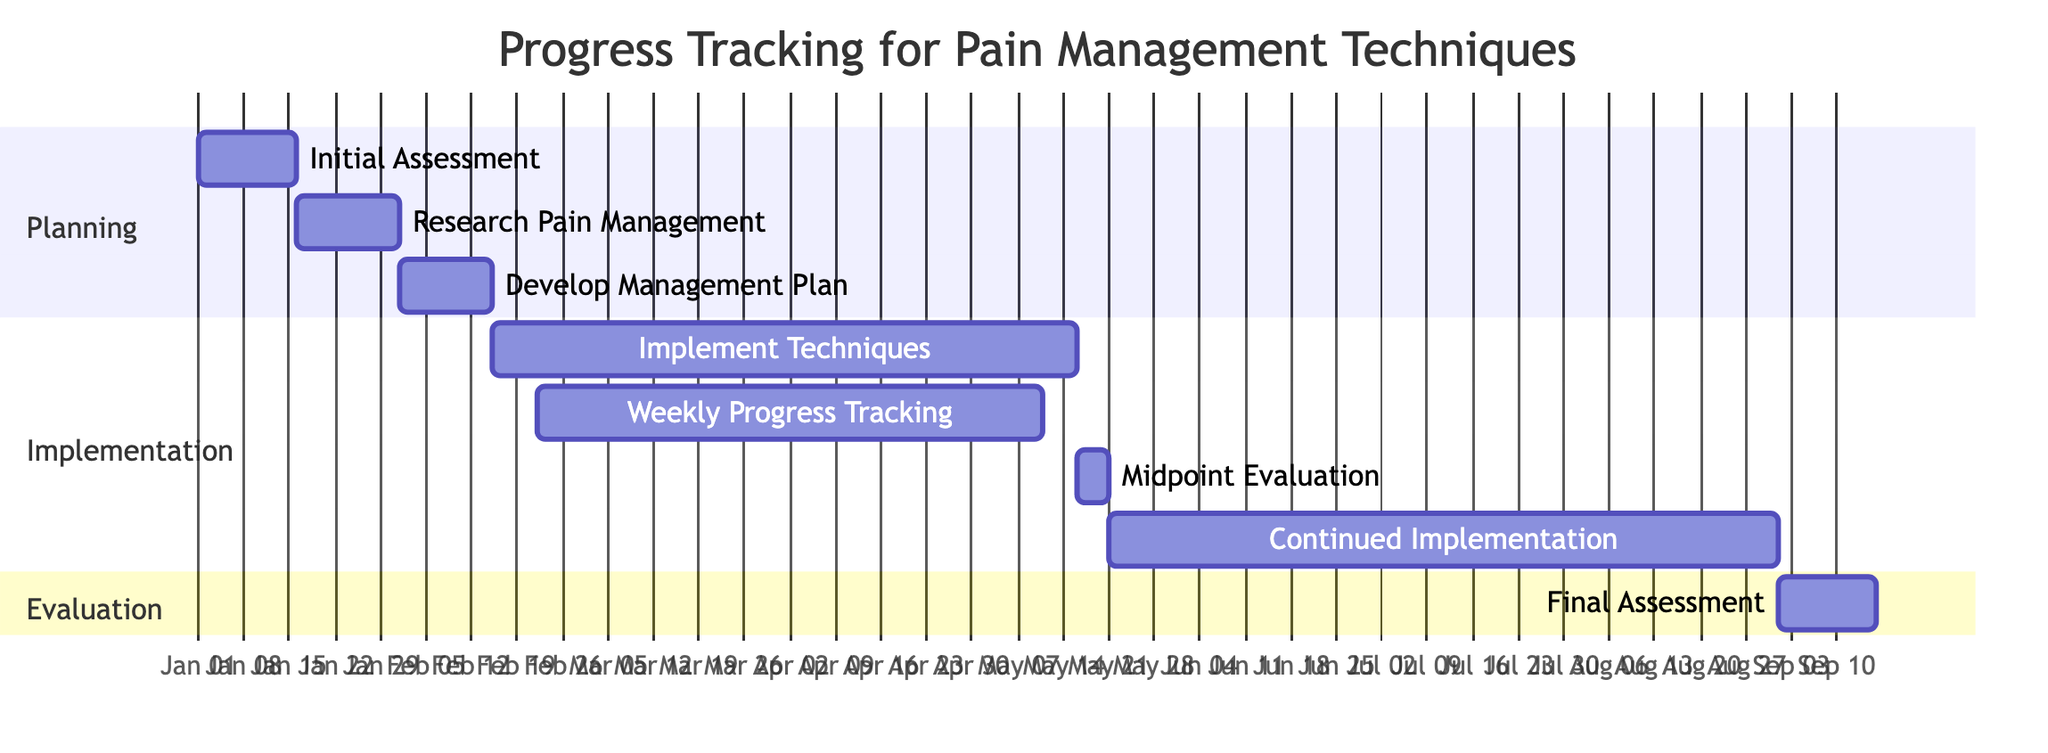What is the duration of the "Initial Assessment"? The "Initial Assessment" task starts on January 1, 2023, and ends on January 15, 2023, which means it lasts for 15 days.
Answer: 15 days What is the start date of "Weekly Progress Tracking"? "Weekly Progress Tracking" begins on February 22, 2023, as indicated in the diagram.
Answer: February 22, 2023 How many days is the "Midpoint Evaluation"? The "Midpoint Evaluation" task lasts from May 16 to May 20, 2023, which is 5 days long.
Answer: 5 days Which task follows "Research Pain Management Techniques"? The task that follows "Research Pain Management Techniques", which ends on January 31, 2023, is "Develop Personalized Pain Management Plan", starting on February 1, 2023.
Answer: Develop Personalized Pain Management Plan What tasks overlap with the "Implement Pain Management Techniques"? "Weekly Progress Tracking" and "Midpoint Evaluation" tasks overlap with "Implement Pain Management Techniques". "Weekly Progress Tracking" starts on February 22 and runs till May 10, while "Midpoint Evaluation" occurs from May 16 to May 20.
Answer: Weekly Progress Tracking, Midpoint Evaluation What is the total number of tasks outlined in the Gantt Chart? The Gantt Chart contains a total of 8 tasks, listed in various sections including Planning, Implementation, and Evaluation.
Answer: 8 tasks How long does the "Continued Implementation & Adjustment" last? "Continued Implementation & Adjustment" starts on May 21, 2023, and extends until August 31, 2023, lasting for 103 days.
Answer: 103 days Which task has the latest end date? The task that has the latest end date is "Final Assessment" which ends on September 15, 2023.
Answer: Final Assessment How many weeks are tracked in the "Weekly Progress Tracking"? "Weekly Progress Tracking" spans from February 22, 2023, to May 10, 2023, covering approximately 11 weeks.
Answer: 11 weeks 